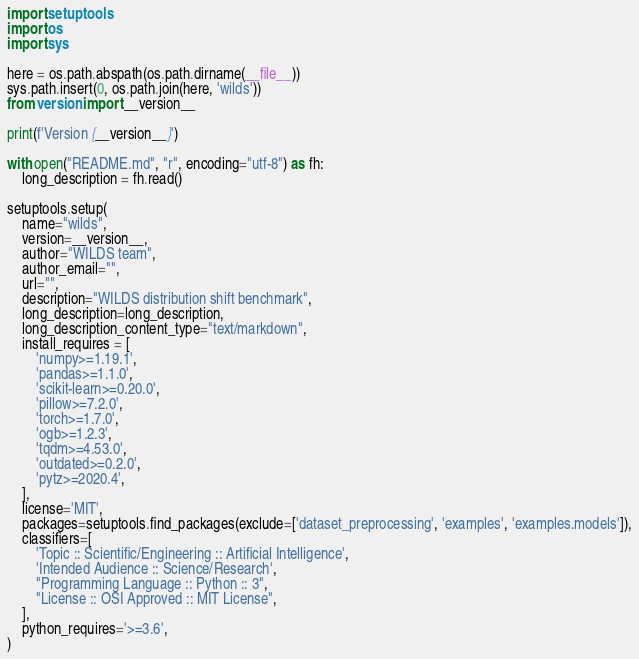Convert code to text. <code><loc_0><loc_0><loc_500><loc_500><_Python_>import setuptools
import os
import sys

here = os.path.abspath(os.path.dirname(__file__))
sys.path.insert(0, os.path.join(here, 'wilds'))
from version import __version__

print(f'Version {__version__}')

with open("README.md", "r", encoding="utf-8") as fh:
    long_description = fh.read()

setuptools.setup(
    name="wilds",
    version=__version__,
    author="WILDS team",
    author_email="",
    url="",
    description="WILDS distribution shift benchmark",
    long_description=long_description,
    long_description_content_type="text/markdown",
    install_requires = [
        'numpy>=1.19.1',
        'pandas>=1.1.0',
        'scikit-learn>=0.20.0',
        'pillow>=7.2.0',
        'torch>=1.7.0',
        'ogb>=1.2.3',
        'tqdm>=4.53.0',
        'outdated>=0.2.0',
        'pytz>=2020.4',
    ],
    license='MIT',
    packages=setuptools.find_packages(exclude=['dataset_preprocessing', 'examples', 'examples.models']),
    classifiers=[
        'Topic :: Scientific/Engineering :: Artificial Intelligence',
        'Intended Audience :: Science/Research',
        "Programming Language :: Python :: 3",
        "License :: OSI Approved :: MIT License",
    ],
    python_requires='>=3.6',
)
</code> 